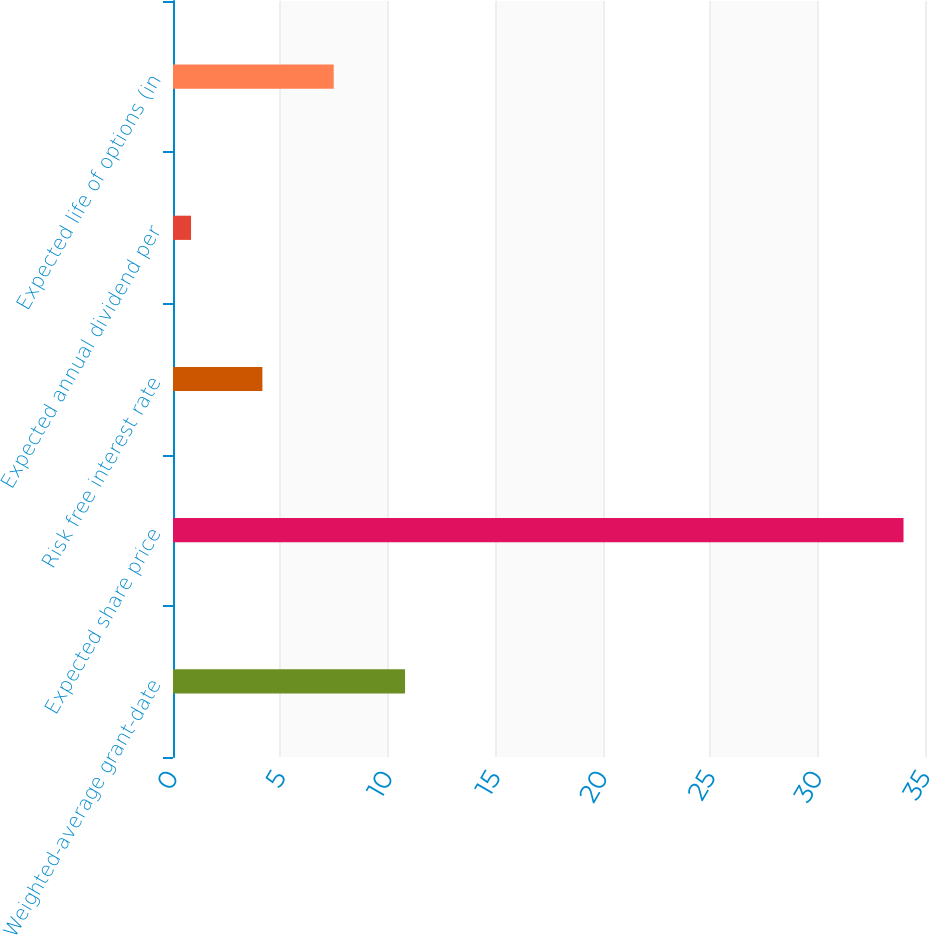Convert chart. <chart><loc_0><loc_0><loc_500><loc_500><bar_chart><fcel>Weighted-average grant-date<fcel>Expected share price<fcel>Risk free interest rate<fcel>Expected annual dividend per<fcel>Expected life of options (in<nl><fcel>10.8<fcel>34<fcel>4.16<fcel>0.84<fcel>7.48<nl></chart> 